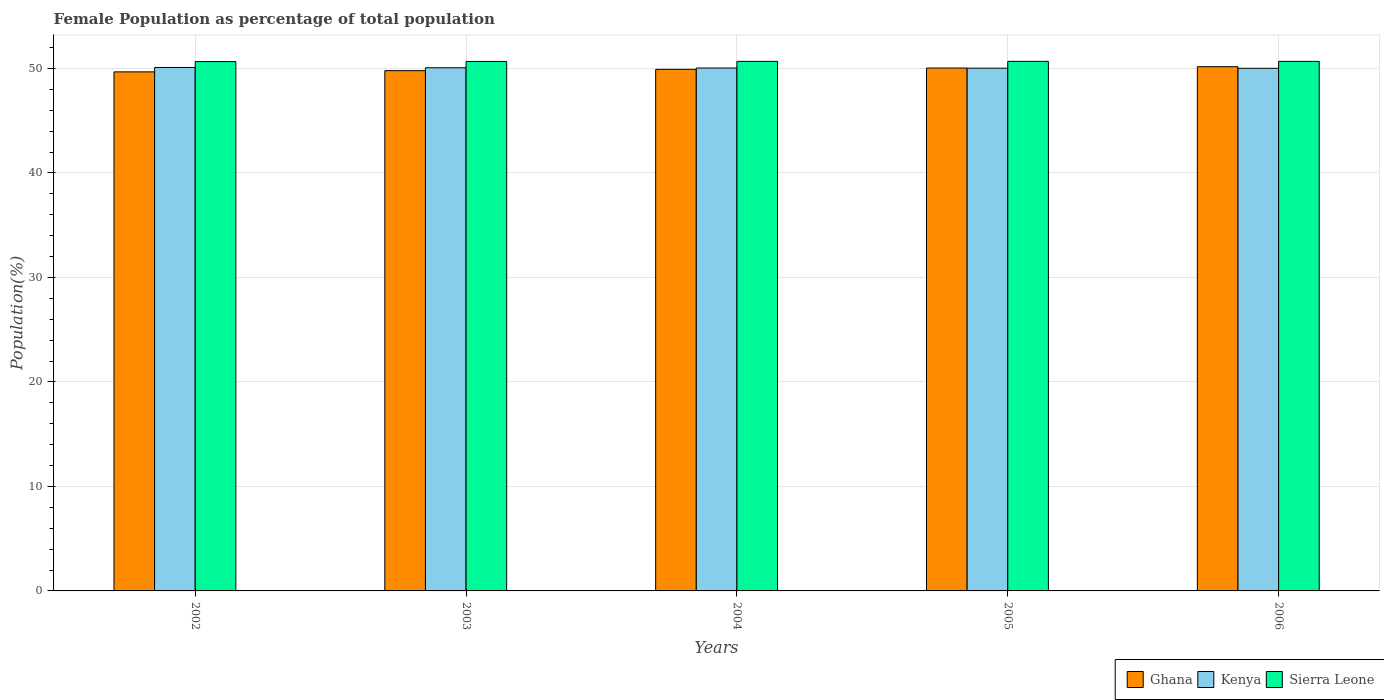How many bars are there on the 1st tick from the right?
Provide a succinct answer. 3. What is the female population in in Kenya in 2002?
Your answer should be very brief. 50.1. Across all years, what is the maximum female population in in Kenya?
Offer a terse response. 50.1. Across all years, what is the minimum female population in in Sierra Leone?
Keep it short and to the point. 50.66. What is the total female population in in Ghana in the graph?
Your answer should be compact. 249.59. What is the difference between the female population in in Sierra Leone in 2002 and that in 2005?
Your answer should be very brief. -0.02. What is the difference between the female population in in Ghana in 2006 and the female population in in Kenya in 2002?
Your answer should be very brief. 0.07. What is the average female population in in Ghana per year?
Offer a terse response. 49.92. In the year 2006, what is the difference between the female population in in Kenya and female population in in Sierra Leone?
Your answer should be compact. -0.66. In how many years, is the female population in in Sierra Leone greater than 50 %?
Provide a succinct answer. 5. What is the ratio of the female population in in Ghana in 2003 to that in 2005?
Your answer should be compact. 1. Is the female population in in Kenya in 2002 less than that in 2003?
Give a very brief answer. No. What is the difference between the highest and the second highest female population in in Kenya?
Ensure brevity in your answer.  0.03. What is the difference between the highest and the lowest female population in in Sierra Leone?
Offer a very short reply. 0.02. What does the 1st bar from the left in 2004 represents?
Offer a very short reply. Ghana. What does the 3rd bar from the right in 2005 represents?
Your response must be concise. Ghana. Is it the case that in every year, the sum of the female population in in Kenya and female population in in Sierra Leone is greater than the female population in in Ghana?
Your answer should be very brief. Yes. Are all the bars in the graph horizontal?
Give a very brief answer. No. What is the difference between two consecutive major ticks on the Y-axis?
Ensure brevity in your answer.  10. Are the values on the major ticks of Y-axis written in scientific E-notation?
Keep it short and to the point. No. Does the graph contain any zero values?
Your answer should be very brief. No. Does the graph contain grids?
Provide a succinct answer. Yes. Where does the legend appear in the graph?
Give a very brief answer. Bottom right. What is the title of the graph?
Provide a short and direct response. Female Population as percentage of total population. Does "Egypt, Arab Rep." appear as one of the legend labels in the graph?
Make the answer very short. No. What is the label or title of the Y-axis?
Offer a very short reply. Population(%). What is the Population(%) in Ghana in 2002?
Provide a short and direct response. 49.68. What is the Population(%) of Kenya in 2002?
Give a very brief answer. 50.1. What is the Population(%) in Sierra Leone in 2002?
Your response must be concise. 50.66. What is the Population(%) in Ghana in 2003?
Keep it short and to the point. 49.79. What is the Population(%) in Kenya in 2003?
Your answer should be compact. 50.07. What is the Population(%) of Sierra Leone in 2003?
Offer a terse response. 50.67. What is the Population(%) in Ghana in 2004?
Give a very brief answer. 49.92. What is the Population(%) of Kenya in 2004?
Your response must be concise. 50.04. What is the Population(%) of Sierra Leone in 2004?
Offer a terse response. 50.68. What is the Population(%) of Ghana in 2005?
Give a very brief answer. 50.04. What is the Population(%) in Kenya in 2005?
Provide a short and direct response. 50.03. What is the Population(%) in Sierra Leone in 2005?
Provide a short and direct response. 50.68. What is the Population(%) of Ghana in 2006?
Your answer should be compact. 50.17. What is the Population(%) of Kenya in 2006?
Ensure brevity in your answer.  50.02. What is the Population(%) in Sierra Leone in 2006?
Offer a terse response. 50.68. Across all years, what is the maximum Population(%) of Ghana?
Make the answer very short. 50.17. Across all years, what is the maximum Population(%) of Kenya?
Keep it short and to the point. 50.1. Across all years, what is the maximum Population(%) in Sierra Leone?
Provide a short and direct response. 50.68. Across all years, what is the minimum Population(%) in Ghana?
Provide a short and direct response. 49.68. Across all years, what is the minimum Population(%) in Kenya?
Offer a terse response. 50.02. Across all years, what is the minimum Population(%) of Sierra Leone?
Provide a succinct answer. 50.66. What is the total Population(%) in Ghana in the graph?
Provide a succinct answer. 249.59. What is the total Population(%) in Kenya in the graph?
Offer a very short reply. 250.25. What is the total Population(%) of Sierra Leone in the graph?
Your response must be concise. 253.37. What is the difference between the Population(%) in Ghana in 2002 and that in 2003?
Make the answer very short. -0.12. What is the difference between the Population(%) of Kenya in 2002 and that in 2003?
Give a very brief answer. 0.03. What is the difference between the Population(%) of Sierra Leone in 2002 and that in 2003?
Offer a terse response. -0.01. What is the difference between the Population(%) in Ghana in 2002 and that in 2004?
Offer a very short reply. -0.24. What is the difference between the Population(%) of Kenya in 2002 and that in 2004?
Your response must be concise. 0.05. What is the difference between the Population(%) in Sierra Leone in 2002 and that in 2004?
Offer a terse response. -0.02. What is the difference between the Population(%) in Ghana in 2002 and that in 2005?
Your response must be concise. -0.37. What is the difference between the Population(%) in Kenya in 2002 and that in 2005?
Your answer should be very brief. 0.07. What is the difference between the Population(%) of Sierra Leone in 2002 and that in 2005?
Offer a terse response. -0.02. What is the difference between the Population(%) of Ghana in 2002 and that in 2006?
Ensure brevity in your answer.  -0.49. What is the difference between the Population(%) of Kenya in 2002 and that in 2006?
Provide a short and direct response. 0.08. What is the difference between the Population(%) in Sierra Leone in 2002 and that in 2006?
Provide a short and direct response. -0.02. What is the difference between the Population(%) of Ghana in 2003 and that in 2004?
Keep it short and to the point. -0.12. What is the difference between the Population(%) in Kenya in 2003 and that in 2004?
Offer a terse response. 0.02. What is the difference between the Population(%) in Sierra Leone in 2003 and that in 2004?
Offer a terse response. -0.01. What is the difference between the Population(%) in Ghana in 2003 and that in 2005?
Offer a terse response. -0.25. What is the difference between the Population(%) in Kenya in 2003 and that in 2005?
Your answer should be very brief. 0.04. What is the difference between the Population(%) in Sierra Leone in 2003 and that in 2005?
Your response must be concise. -0.01. What is the difference between the Population(%) in Ghana in 2003 and that in 2006?
Your answer should be very brief. -0.38. What is the difference between the Population(%) in Kenya in 2003 and that in 2006?
Give a very brief answer. 0.05. What is the difference between the Population(%) in Sierra Leone in 2003 and that in 2006?
Provide a short and direct response. -0. What is the difference between the Population(%) in Ghana in 2004 and that in 2005?
Provide a succinct answer. -0.12. What is the difference between the Population(%) of Kenya in 2004 and that in 2005?
Make the answer very short. 0.02. What is the difference between the Population(%) in Sierra Leone in 2004 and that in 2005?
Offer a terse response. -0. What is the difference between the Population(%) in Ghana in 2004 and that in 2006?
Your answer should be compact. -0.25. What is the difference between the Population(%) of Kenya in 2004 and that in 2006?
Your response must be concise. 0.03. What is the difference between the Population(%) of Sierra Leone in 2004 and that in 2006?
Your response must be concise. 0. What is the difference between the Population(%) in Ghana in 2005 and that in 2006?
Provide a short and direct response. -0.13. What is the difference between the Population(%) of Kenya in 2005 and that in 2006?
Offer a very short reply. 0.01. What is the difference between the Population(%) of Sierra Leone in 2005 and that in 2006?
Provide a succinct answer. 0. What is the difference between the Population(%) in Ghana in 2002 and the Population(%) in Kenya in 2003?
Offer a very short reply. -0.39. What is the difference between the Population(%) in Ghana in 2002 and the Population(%) in Sierra Leone in 2003?
Provide a short and direct response. -1. What is the difference between the Population(%) of Kenya in 2002 and the Population(%) of Sierra Leone in 2003?
Offer a terse response. -0.58. What is the difference between the Population(%) of Ghana in 2002 and the Population(%) of Kenya in 2004?
Ensure brevity in your answer.  -0.37. What is the difference between the Population(%) in Ghana in 2002 and the Population(%) in Sierra Leone in 2004?
Offer a very short reply. -1. What is the difference between the Population(%) of Kenya in 2002 and the Population(%) of Sierra Leone in 2004?
Provide a succinct answer. -0.58. What is the difference between the Population(%) in Ghana in 2002 and the Population(%) in Kenya in 2005?
Provide a short and direct response. -0.35. What is the difference between the Population(%) of Ghana in 2002 and the Population(%) of Sierra Leone in 2005?
Provide a succinct answer. -1.01. What is the difference between the Population(%) in Kenya in 2002 and the Population(%) in Sierra Leone in 2005?
Provide a succinct answer. -0.59. What is the difference between the Population(%) of Ghana in 2002 and the Population(%) of Kenya in 2006?
Provide a succinct answer. -0.34. What is the difference between the Population(%) of Ghana in 2002 and the Population(%) of Sierra Leone in 2006?
Offer a very short reply. -1. What is the difference between the Population(%) in Kenya in 2002 and the Population(%) in Sierra Leone in 2006?
Provide a succinct answer. -0.58. What is the difference between the Population(%) in Ghana in 2003 and the Population(%) in Kenya in 2004?
Offer a very short reply. -0.25. What is the difference between the Population(%) of Ghana in 2003 and the Population(%) of Sierra Leone in 2004?
Your answer should be compact. -0.89. What is the difference between the Population(%) in Kenya in 2003 and the Population(%) in Sierra Leone in 2004?
Ensure brevity in your answer.  -0.61. What is the difference between the Population(%) of Ghana in 2003 and the Population(%) of Kenya in 2005?
Your answer should be very brief. -0.24. What is the difference between the Population(%) in Ghana in 2003 and the Population(%) in Sierra Leone in 2005?
Ensure brevity in your answer.  -0.89. What is the difference between the Population(%) of Kenya in 2003 and the Population(%) of Sierra Leone in 2005?
Your response must be concise. -0.61. What is the difference between the Population(%) in Ghana in 2003 and the Population(%) in Kenya in 2006?
Provide a short and direct response. -0.22. What is the difference between the Population(%) in Ghana in 2003 and the Population(%) in Sierra Leone in 2006?
Keep it short and to the point. -0.88. What is the difference between the Population(%) in Kenya in 2003 and the Population(%) in Sierra Leone in 2006?
Provide a succinct answer. -0.61. What is the difference between the Population(%) of Ghana in 2004 and the Population(%) of Kenya in 2005?
Offer a terse response. -0.11. What is the difference between the Population(%) of Ghana in 2004 and the Population(%) of Sierra Leone in 2005?
Provide a succinct answer. -0.76. What is the difference between the Population(%) of Kenya in 2004 and the Population(%) of Sierra Leone in 2005?
Ensure brevity in your answer.  -0.64. What is the difference between the Population(%) in Ghana in 2004 and the Population(%) in Kenya in 2006?
Ensure brevity in your answer.  -0.1. What is the difference between the Population(%) of Ghana in 2004 and the Population(%) of Sierra Leone in 2006?
Give a very brief answer. -0.76. What is the difference between the Population(%) of Kenya in 2004 and the Population(%) of Sierra Leone in 2006?
Make the answer very short. -0.63. What is the difference between the Population(%) of Ghana in 2005 and the Population(%) of Kenya in 2006?
Your answer should be compact. 0.02. What is the difference between the Population(%) in Ghana in 2005 and the Population(%) in Sierra Leone in 2006?
Provide a short and direct response. -0.64. What is the difference between the Population(%) of Kenya in 2005 and the Population(%) of Sierra Leone in 2006?
Ensure brevity in your answer.  -0.65. What is the average Population(%) of Ghana per year?
Give a very brief answer. 49.92. What is the average Population(%) of Kenya per year?
Ensure brevity in your answer.  50.05. What is the average Population(%) in Sierra Leone per year?
Your answer should be compact. 50.67. In the year 2002, what is the difference between the Population(%) of Ghana and Population(%) of Kenya?
Your answer should be very brief. -0.42. In the year 2002, what is the difference between the Population(%) of Ghana and Population(%) of Sierra Leone?
Make the answer very short. -0.98. In the year 2002, what is the difference between the Population(%) in Kenya and Population(%) in Sierra Leone?
Keep it short and to the point. -0.56. In the year 2003, what is the difference between the Population(%) of Ghana and Population(%) of Kenya?
Offer a terse response. -0.28. In the year 2003, what is the difference between the Population(%) of Ghana and Population(%) of Sierra Leone?
Give a very brief answer. -0.88. In the year 2003, what is the difference between the Population(%) of Kenya and Population(%) of Sierra Leone?
Give a very brief answer. -0.6. In the year 2004, what is the difference between the Population(%) of Ghana and Population(%) of Kenya?
Ensure brevity in your answer.  -0.13. In the year 2004, what is the difference between the Population(%) in Ghana and Population(%) in Sierra Leone?
Provide a short and direct response. -0.76. In the year 2004, what is the difference between the Population(%) in Kenya and Population(%) in Sierra Leone?
Offer a very short reply. -0.64. In the year 2005, what is the difference between the Population(%) of Ghana and Population(%) of Kenya?
Provide a succinct answer. 0.01. In the year 2005, what is the difference between the Population(%) of Ghana and Population(%) of Sierra Leone?
Your response must be concise. -0.64. In the year 2005, what is the difference between the Population(%) of Kenya and Population(%) of Sierra Leone?
Your response must be concise. -0.65. In the year 2006, what is the difference between the Population(%) of Ghana and Population(%) of Kenya?
Give a very brief answer. 0.15. In the year 2006, what is the difference between the Population(%) in Ghana and Population(%) in Sierra Leone?
Offer a very short reply. -0.51. In the year 2006, what is the difference between the Population(%) in Kenya and Population(%) in Sierra Leone?
Offer a terse response. -0.66. What is the ratio of the Population(%) of Ghana in 2002 to that in 2003?
Make the answer very short. 1. What is the ratio of the Population(%) in Kenya in 2002 to that in 2004?
Make the answer very short. 1. What is the ratio of the Population(%) of Sierra Leone in 2002 to that in 2004?
Make the answer very short. 1. What is the ratio of the Population(%) in Kenya in 2002 to that in 2005?
Make the answer very short. 1. What is the ratio of the Population(%) in Sierra Leone in 2002 to that in 2005?
Your answer should be very brief. 1. What is the ratio of the Population(%) of Ghana in 2002 to that in 2006?
Keep it short and to the point. 0.99. What is the ratio of the Population(%) in Kenya in 2002 to that in 2006?
Offer a very short reply. 1. What is the ratio of the Population(%) of Ghana in 2003 to that in 2004?
Make the answer very short. 1. What is the ratio of the Population(%) of Sierra Leone in 2003 to that in 2004?
Offer a very short reply. 1. What is the ratio of the Population(%) in Kenya in 2003 to that in 2005?
Your response must be concise. 1. What is the ratio of the Population(%) in Sierra Leone in 2003 to that in 2005?
Your response must be concise. 1. What is the ratio of the Population(%) of Sierra Leone in 2003 to that in 2006?
Provide a short and direct response. 1. What is the ratio of the Population(%) of Sierra Leone in 2004 to that in 2005?
Provide a succinct answer. 1. What is the ratio of the Population(%) in Sierra Leone in 2004 to that in 2006?
Provide a short and direct response. 1. What is the difference between the highest and the second highest Population(%) in Ghana?
Your answer should be very brief. 0.13. What is the difference between the highest and the second highest Population(%) in Kenya?
Make the answer very short. 0.03. What is the difference between the highest and the second highest Population(%) of Sierra Leone?
Your response must be concise. 0. What is the difference between the highest and the lowest Population(%) of Ghana?
Your answer should be compact. 0.49. What is the difference between the highest and the lowest Population(%) in Kenya?
Offer a terse response. 0.08. What is the difference between the highest and the lowest Population(%) of Sierra Leone?
Give a very brief answer. 0.02. 